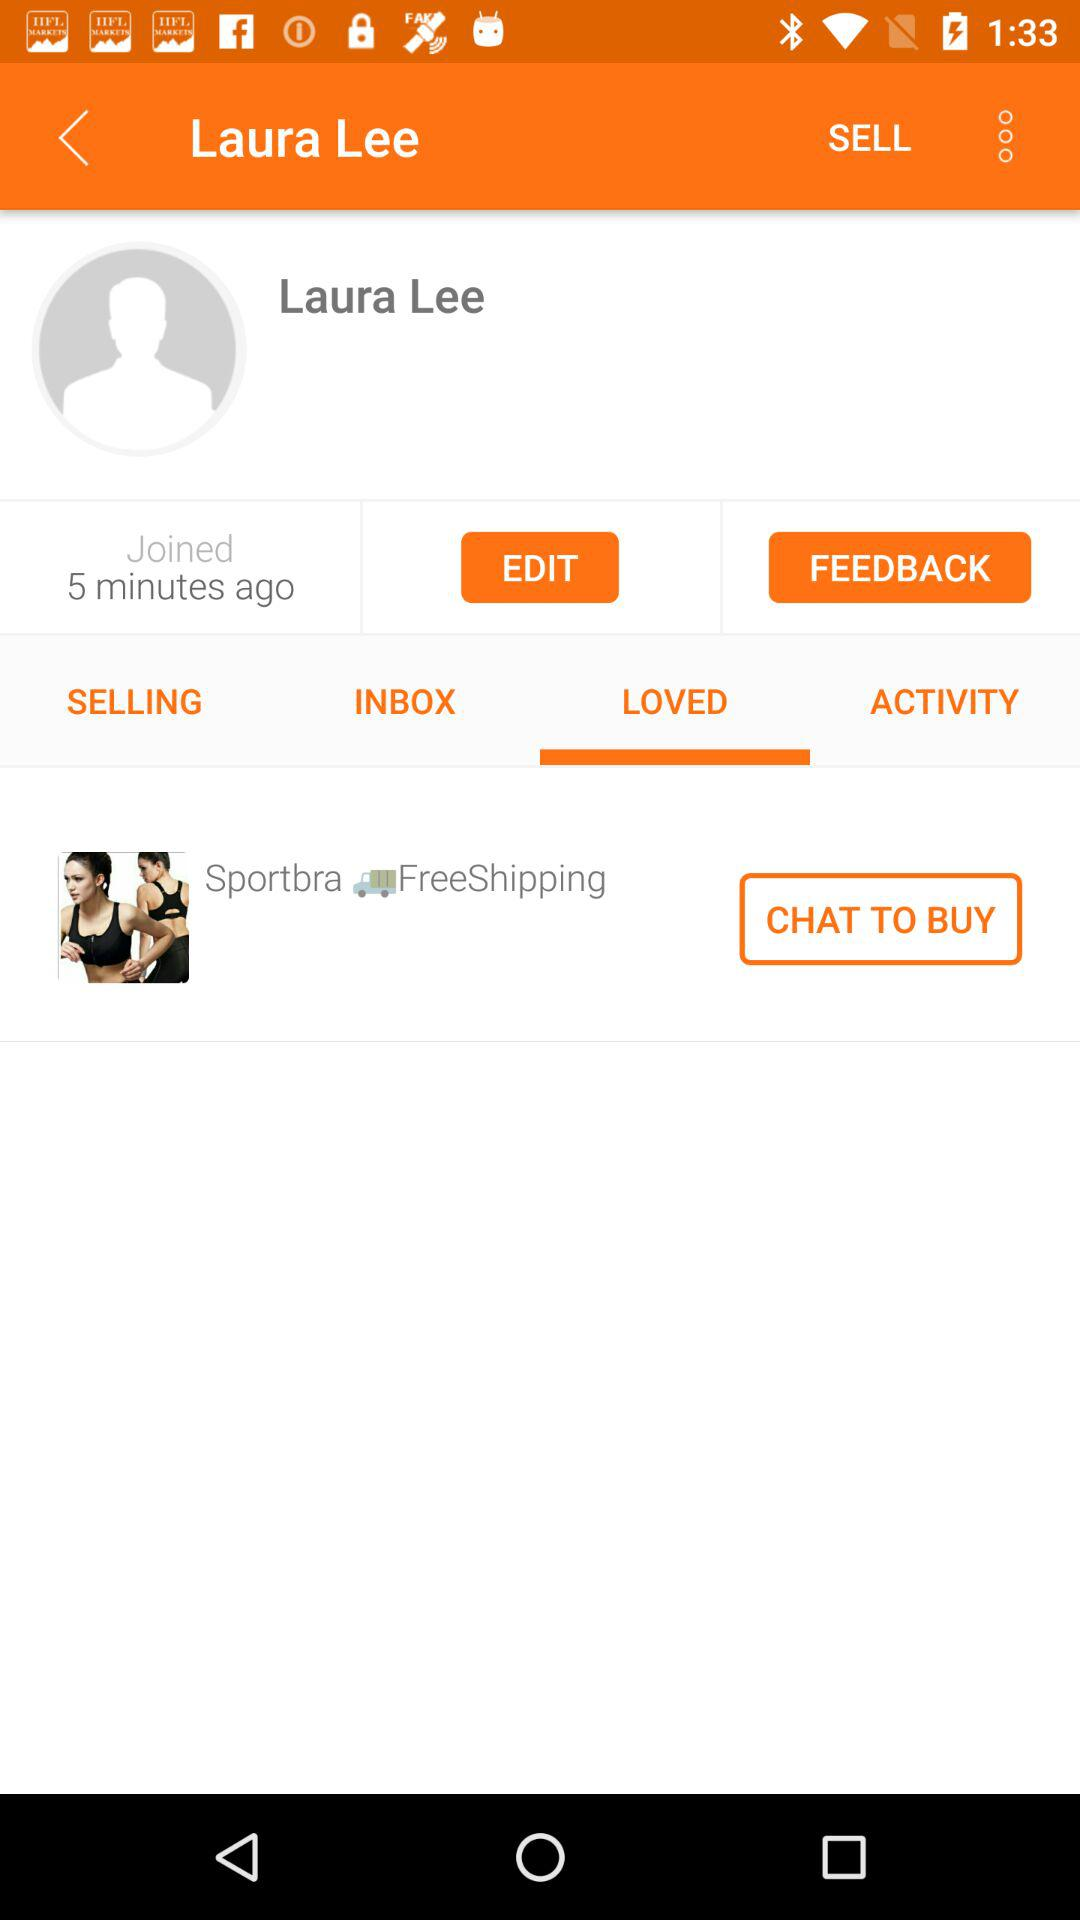Which tab is selected? The selected tab is "LOVED". 